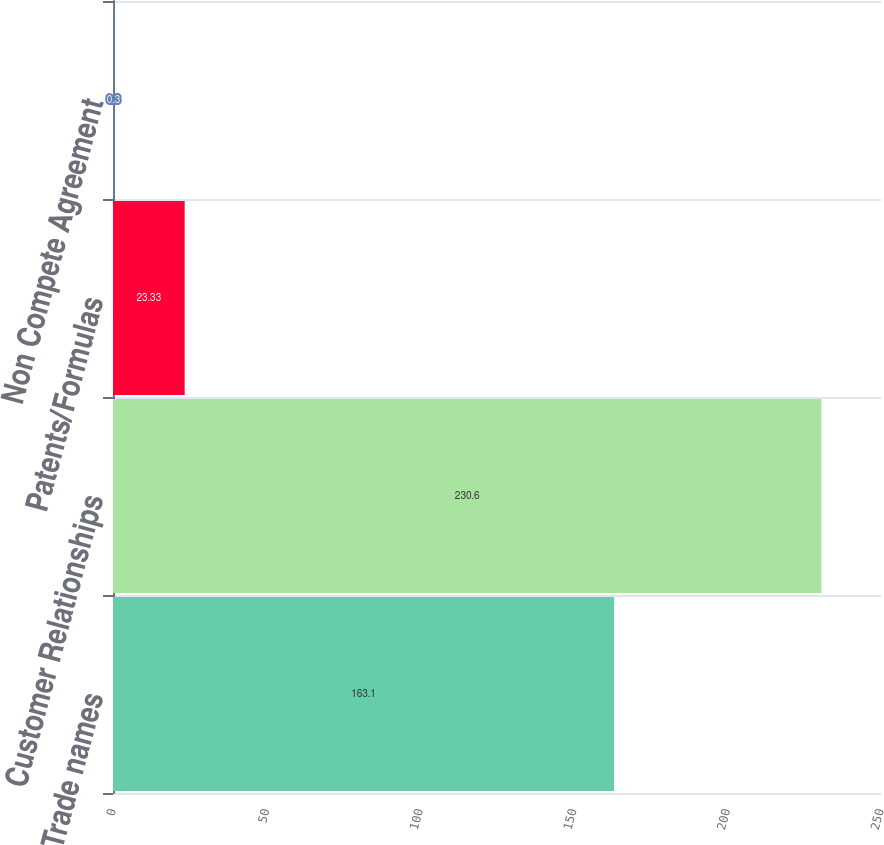<chart> <loc_0><loc_0><loc_500><loc_500><bar_chart><fcel>Trade names<fcel>Customer Relationships<fcel>Patents/Formulas<fcel>Non Compete Agreement<nl><fcel>163.1<fcel>230.6<fcel>23.33<fcel>0.3<nl></chart> 